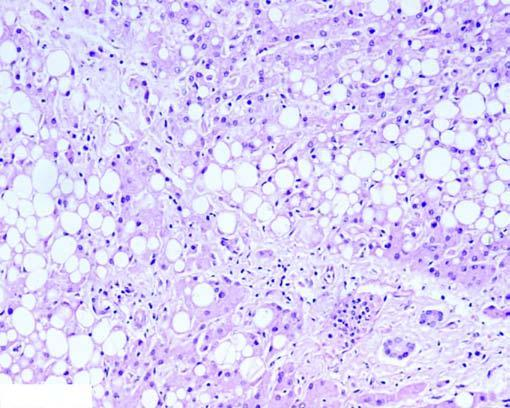what are distended with large fat vacuoles pushing the nuclei to the periphery (macrovesicles), while others show multiple small vacuoles in the cytoplasm (microvesicles)?
Answer the question using a single word or phrase. Many of hepatocytes 